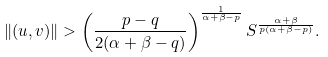<formula> <loc_0><loc_0><loc_500><loc_500>\| ( u , v ) \| > \left ( \frac { p - q } { 2 ( \alpha + \beta - q ) } \right ) ^ { \frac { 1 } { \alpha + \beta - p } } S ^ { \frac { \alpha + \beta } { p ( \alpha + \beta - p ) } } .</formula> 